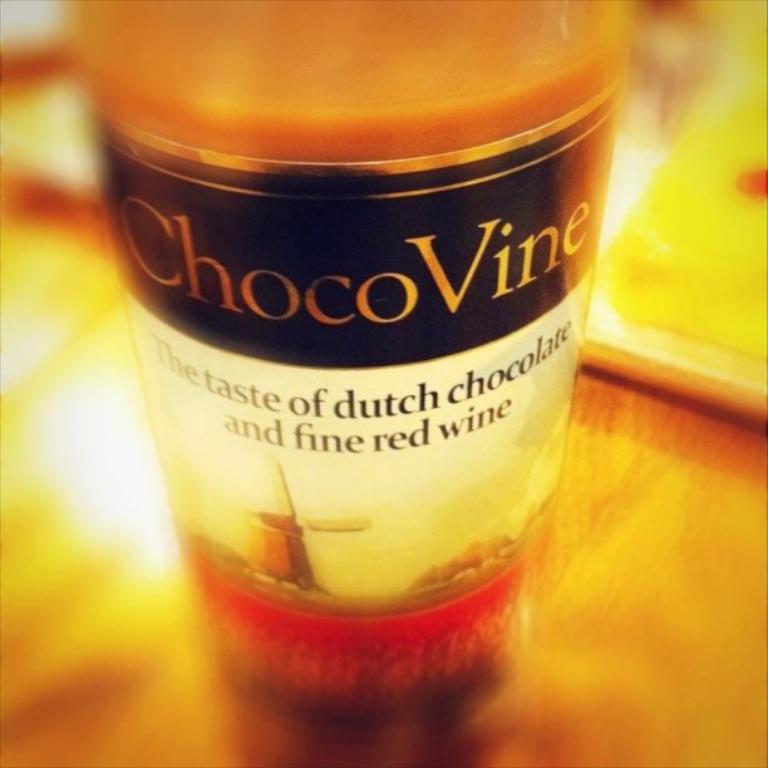What does this "fine red wine" taste like?
Offer a very short reply. Dutch chocolate. What does the wine bottle say?
Provide a succinct answer. Chocovine. 